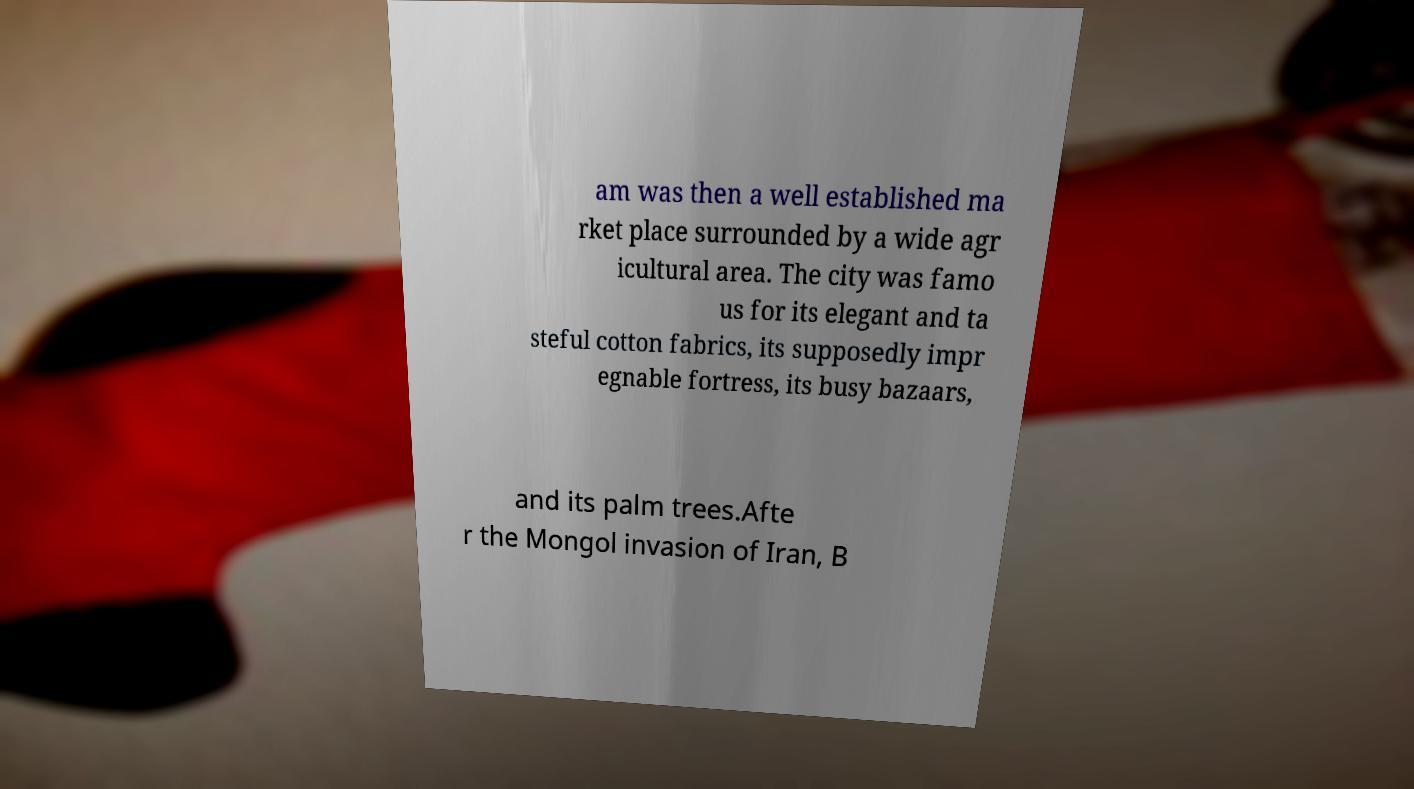Can you accurately transcribe the text from the provided image for me? am was then a well established ma rket place surrounded by a wide agr icultural area. The city was famo us for its elegant and ta steful cotton fabrics, its supposedly impr egnable fortress, its busy bazaars, and its palm trees.Afte r the Mongol invasion of Iran, B 